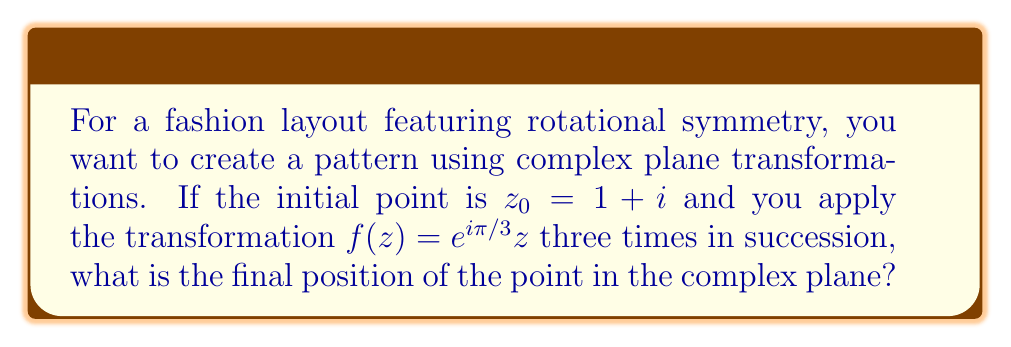Help me with this question. Let's approach this step-by-step:

1) We start with $z_0 = 1 + i$

2) The transformation $f(z) = e^{i\pi/3}z$ rotates a point by $60°$ (or $\pi/3$ radians) counterclockwise around the origin.

3) We need to apply this transformation three times. Let's call the intermediate results $z_1$, $z_2$, and $z_3$.

4) First application:
   $z_1 = f(z_0) = e^{i\pi/3}(1+i)$

5) Second application:
   $z_2 = f(z_1) = e^{i\pi/3}(e^{i\pi/3}(1+i)) = e^{2i\pi/3}(1+i)$

6) Third application:
   $z_3 = f(z_2) = e^{i\pi/3}(e^{2i\pi/3}(1+i)) = e^{i\pi}(1+i)$

7) We know that $e^{i\pi} = -1$, so:
   $z_3 = -1(1+i) = -1 - i$

Therefore, after three applications of the transformation, the point ends up at $-1 - i$ in the complex plane.
Answer: $-1 - i$ 